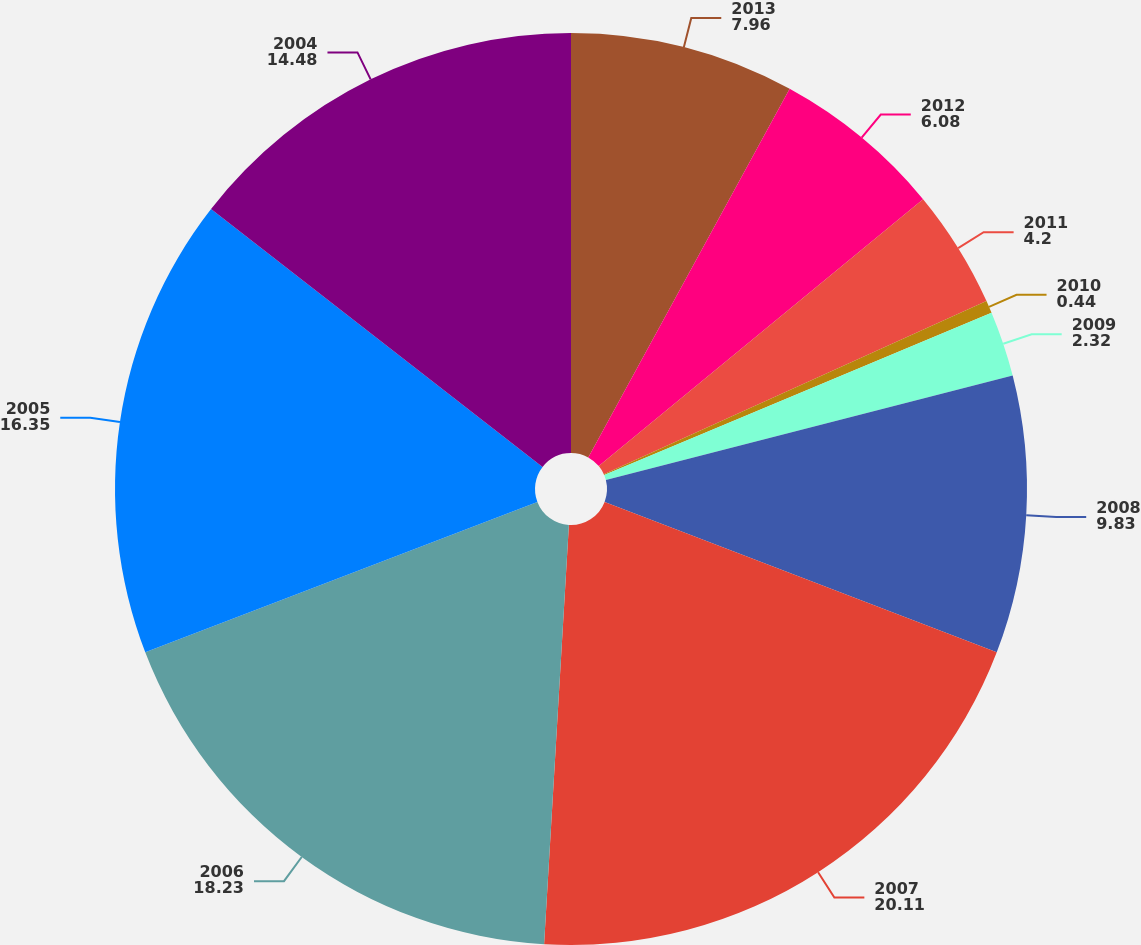<chart> <loc_0><loc_0><loc_500><loc_500><pie_chart><fcel>2013<fcel>2012<fcel>2011<fcel>2010<fcel>2009<fcel>2008<fcel>2007<fcel>2006<fcel>2005<fcel>2004<nl><fcel>7.96%<fcel>6.08%<fcel>4.2%<fcel>0.44%<fcel>2.32%<fcel>9.83%<fcel>20.11%<fcel>18.23%<fcel>16.35%<fcel>14.48%<nl></chart> 